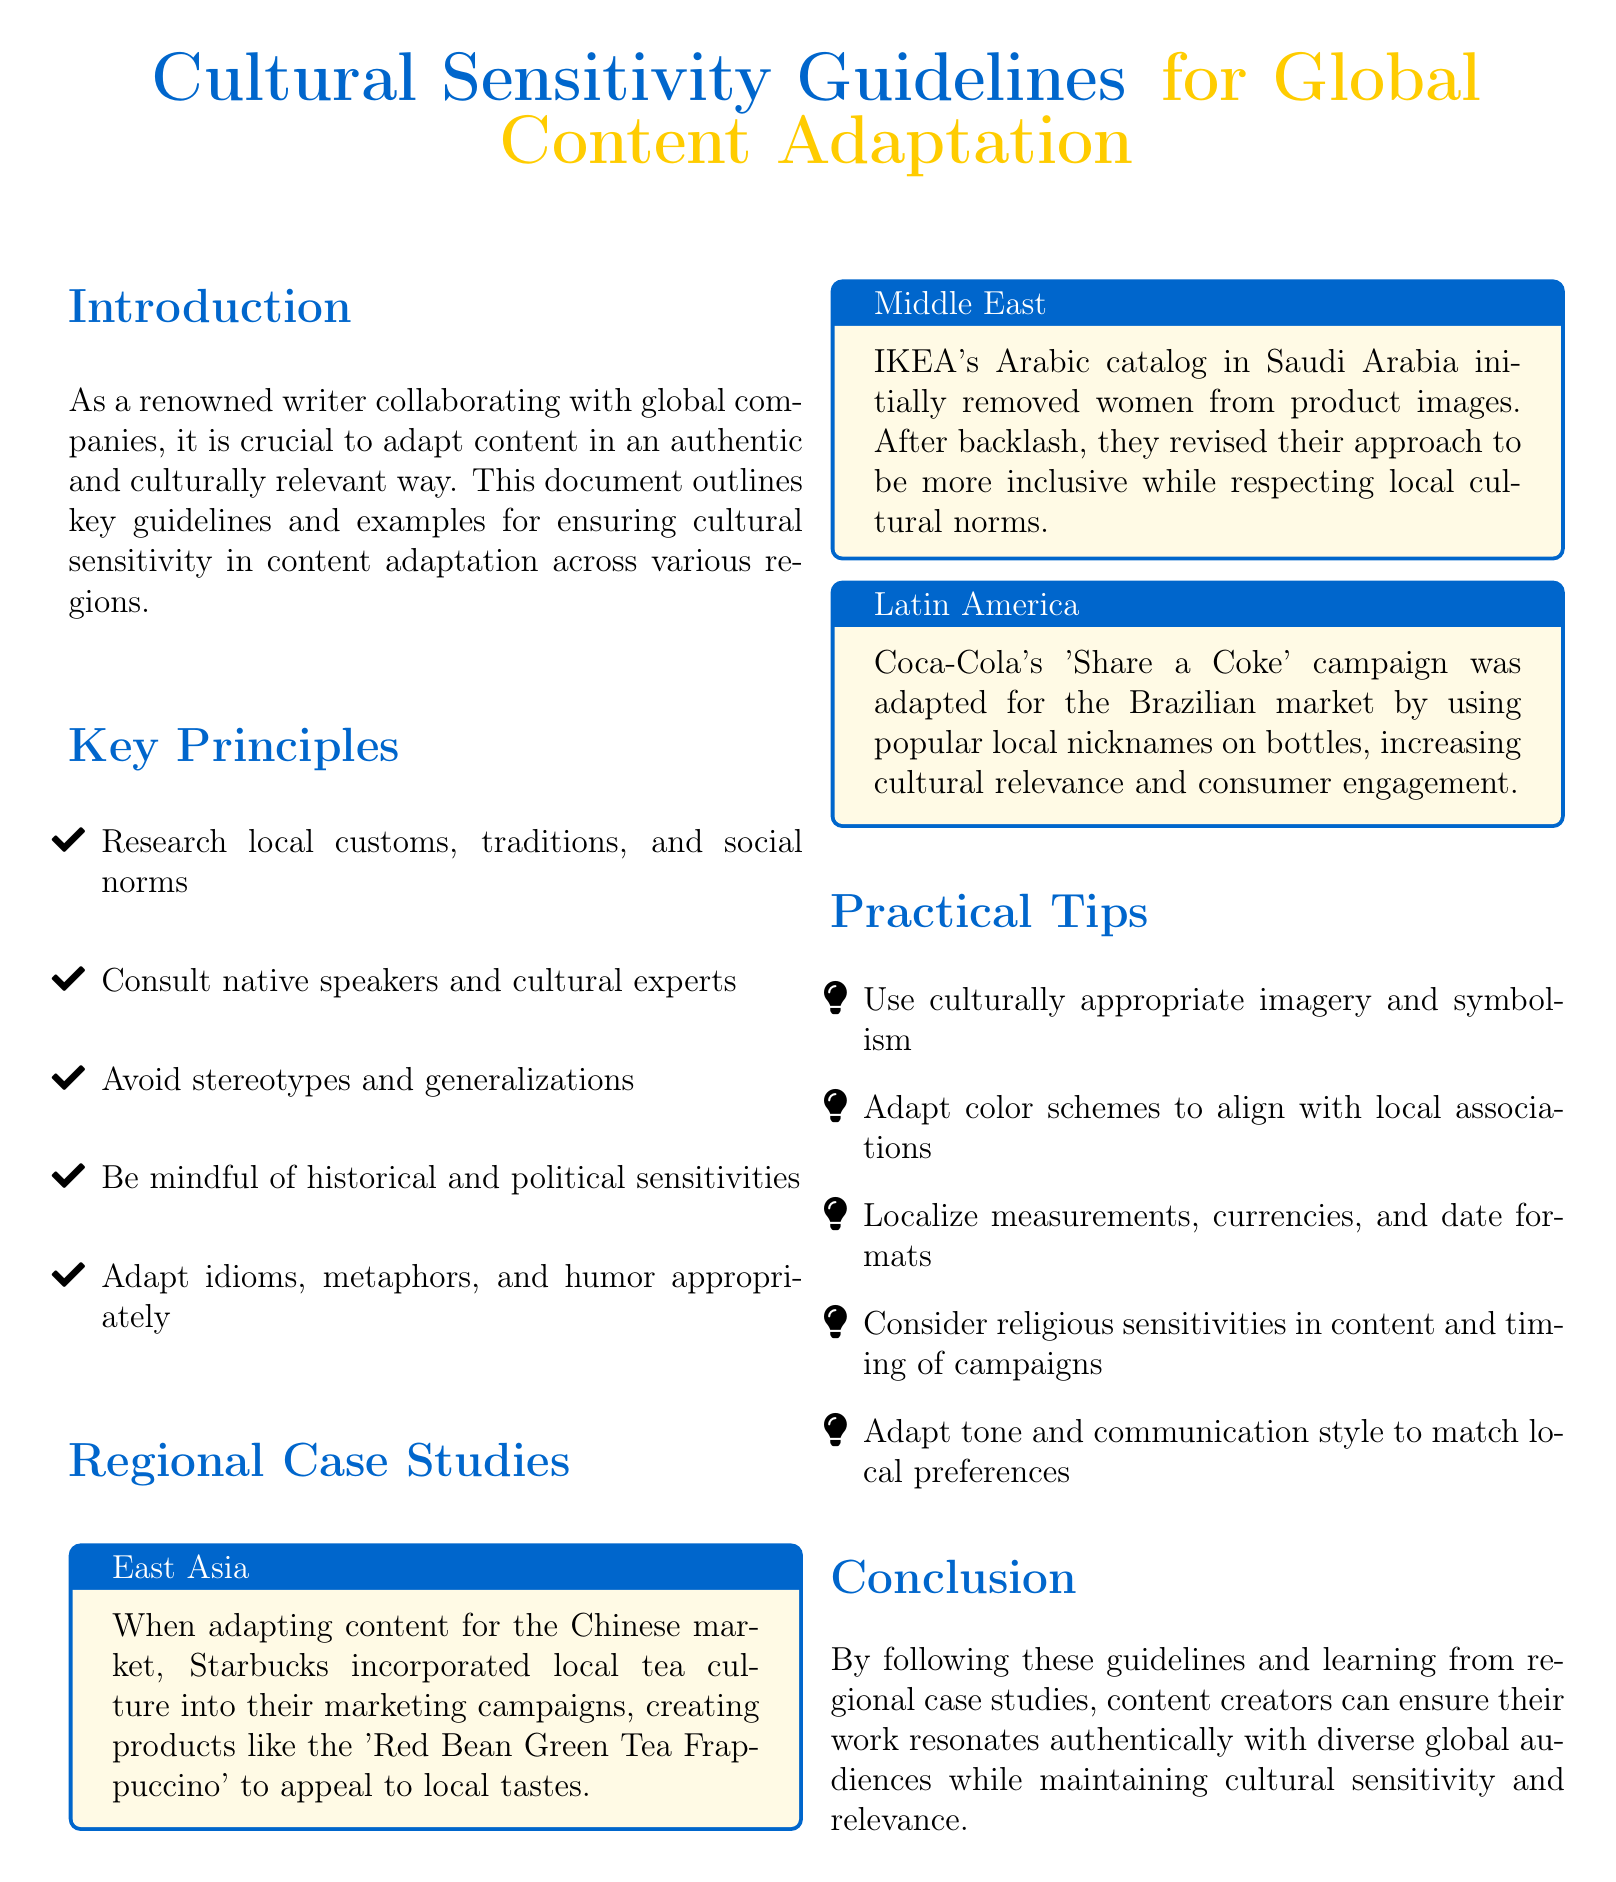what is the main title of the document? The main title is emphasized in a larger font at the beginning of the document, which is "Cultural Sensitivity Guidelines for Global Content Adaptation."
Answer: Cultural Sensitivity Guidelines for Global Content Adaptation what is one key principle mentioned in the document? The document lists several key principles for cultural sensitivity, one of which is "Research local customs, traditions, and social norms."
Answer: Research local customs, traditions, and social norms which company adapted its marketing for the Chinese market? The document provides a case study about a company's adaptation specifically for China, mentioning Starbucks and their product adaptation.
Answer: Starbucks what did IKEA initially remove from their Arabic catalog? The specific detail in the case study regarding IKEA addresses a significant change made in their catalog. It states they removed "women from product images."
Answer: women from product images how did Coca-Cola increase cultural relevance in Brazil? The document includes a case study that explains Coca-Cola's adaptation strategy, which involved using "popular local nicknames on bottles."
Answer: popular local nicknames on bottles what visual elements should be considered for cultural sensitivity? The document provides practical tips regarding the use of imagery, stating one such tip is to "Use culturally appropriate imagery and symbolism."
Answer: Use culturally appropriate imagery and symbolism how many regional case studies are presented in the document? The number of case studies is directly mentioned in the document, with each case study detailing a different region. The document explicitly mentions three such case studies.
Answer: three what is one reason for consulting native speakers? The document emphasizes the importance of consulting native speakers under the key principles, which helps ensure "cultural relevance."
Answer: cultural relevance which cultural aspect did IKEA revise after backlash? The case study on IKEA highlights the response to local sentiment, particularly emphasizing that they made their approach "more inclusive."
Answer: more inclusive 